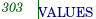<code> <loc_0><loc_0><loc_500><loc_500><_SQL_>VALUES</code> 